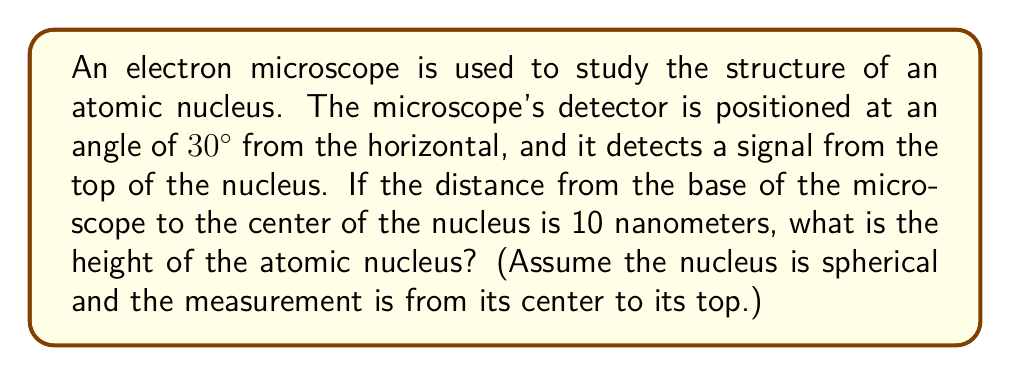What is the answer to this math problem? To solve this problem, we can use basic trigonometry. Let's break it down step-by-step:

1) First, let's visualize the problem:

   [asy]
   import geometry;
   
   size(200);
   
   pair O=(0,0), A=(10,0), B=(10,5.77);
   
   draw(O--A--B--O);
   
   label("30°", O, SW);
   label("10 nm", (5,0), S);
   label("h", (10,2.885), E);
   
   dot("Center", O);
   dot("Base", A);
   dot("Top", B);
   [/asy]

2) In this right-angled triangle, we know:
   - The angle at the base is 30°
   - The adjacent side (from the center to the base of the microscope) is 10 nm

3) We need to find the opposite side, which represents the height of the nucleus.

4) This is a perfect scenario to use the tangent ratio. Recall that:

   $$ \tan \theta = \frac{\text{opposite}}{\text{adjacent}} $$

5) Substituting our known values:

   $$ \tan 30° = \frac{h}{10} $$

6) We know that $\tan 30° = \frac{1}{\sqrt{3}}$, so:

   $$ \frac{1}{\sqrt{3}} = \frac{h}{10} $$

7) Cross multiply:

   $$ 10 \cdot \frac{1}{\sqrt{3}} = h $$

8) Simplify:

   $$ h = \frac{10}{\sqrt{3}} \approx 5.77 \text{ nm} $$

Therefore, the height of the atomic nucleus is approximately 5.77 nanometers.
Answer: The height of the atomic nucleus is $\frac{10}{\sqrt{3}} \approx 5.77$ nanometers. 